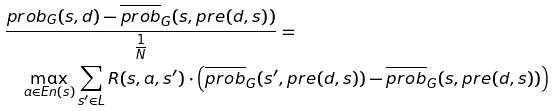<formula> <loc_0><loc_0><loc_500><loc_500>& \frac { p r o b _ { G } ( s , d ) - \overline { p r o b } _ { G } ( s , p r e ( d , s ) ) } { \frac { 1 } { N } } = \\ & \quad \max _ { a \in E n ( s ) } \sum _ { s ^ { \prime } \in L } R ( s , a , s ^ { \prime } ) \cdot \left ( \overline { p r o b } _ { G } ( s ^ { \prime } , p r e ( d , s ) ) - \overline { p r o b } _ { G } ( s , p r e ( d , s ) ) \right )</formula> 